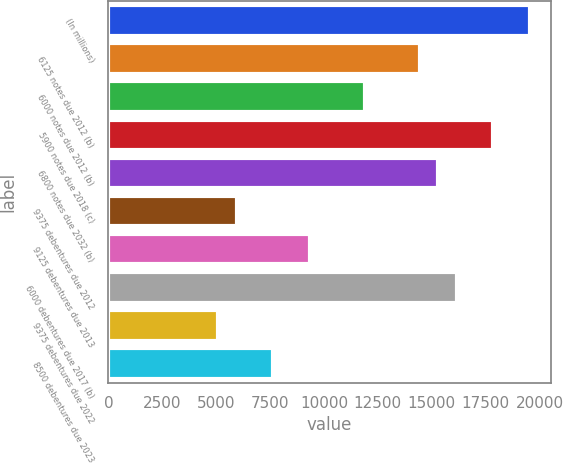Convert chart. <chart><loc_0><loc_0><loc_500><loc_500><bar_chart><fcel>(In millions)<fcel>6125 notes due 2012 (b)<fcel>6000 notes due 2012 (b)<fcel>5900 notes due 2018 (c)<fcel>6800 notes due 2032 (b)<fcel>9375 debentures due 2012<fcel>9125 debentures due 2013<fcel>6000 debentures due 2017 (b)<fcel>9375 debentures due 2022<fcel>8500 debentures due 2023<nl><fcel>19550.7<fcel>14451.3<fcel>11901.6<fcel>17850.9<fcel>15301.2<fcel>5952.3<fcel>9351.9<fcel>16151.1<fcel>5102.4<fcel>7652.1<nl></chart> 